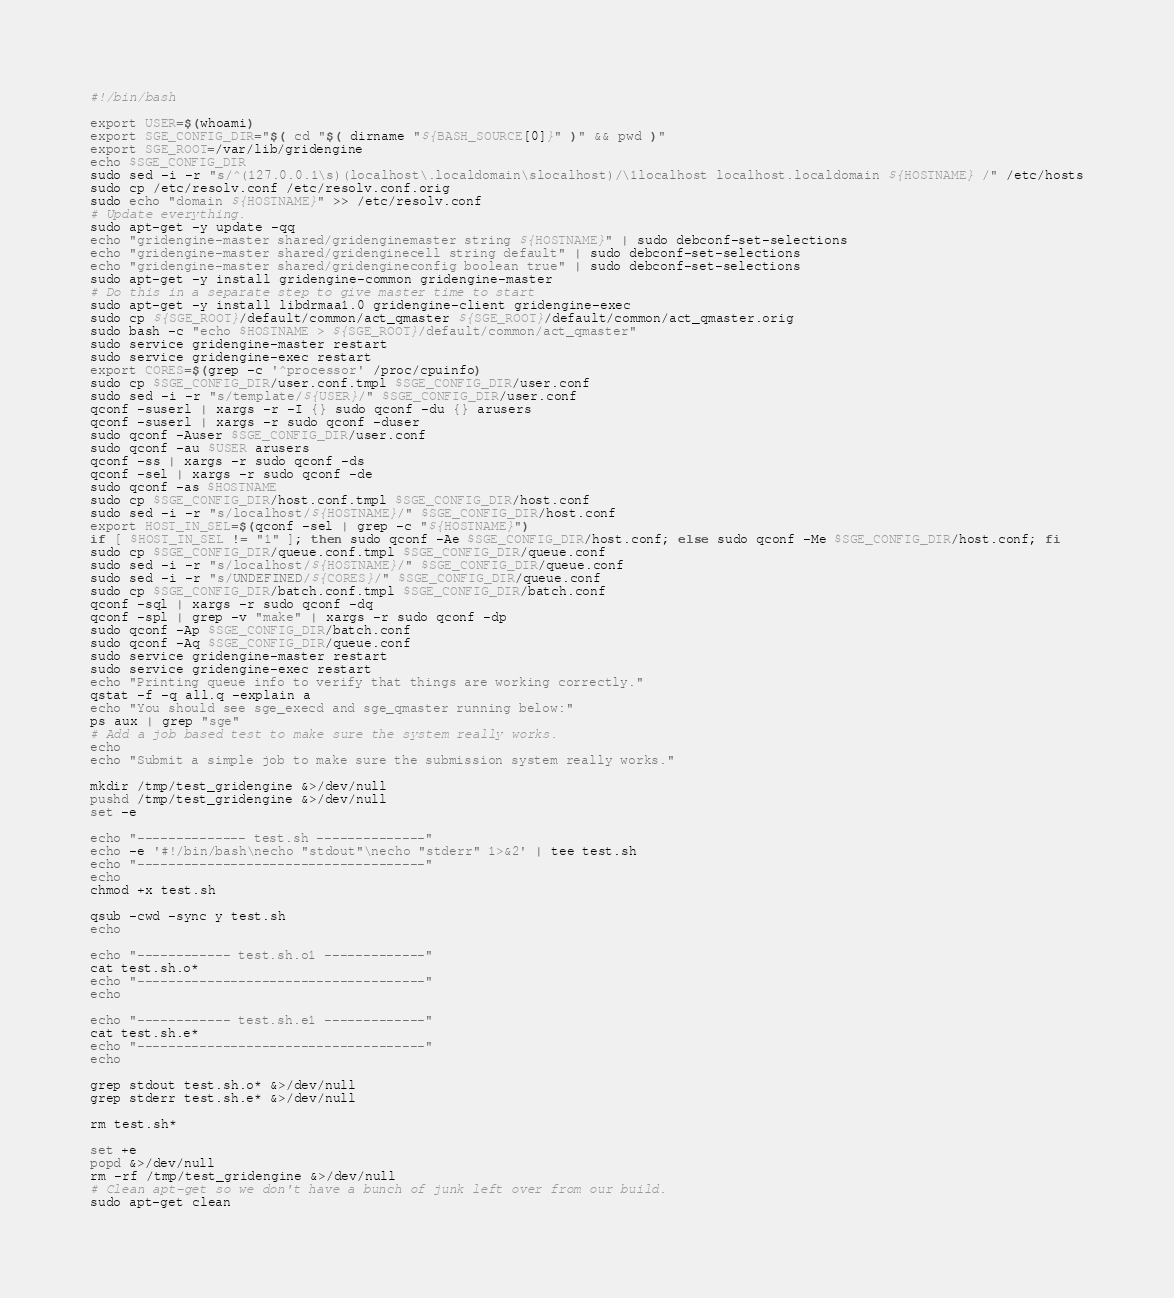Convert code to text. <code><loc_0><loc_0><loc_500><loc_500><_Bash_>#!/bin/bash

export USER=$(whoami)
export SGE_CONFIG_DIR="$( cd "$( dirname "${BASH_SOURCE[0]}" )" && pwd )"
export SGE_ROOT=/var/lib/gridengine
echo $SGE_CONFIG_DIR
sudo sed -i -r "s/^(127.0.0.1\s)(localhost\.localdomain\slocalhost)/\1localhost localhost.localdomain ${HOSTNAME} /" /etc/hosts
sudo cp /etc/resolv.conf /etc/resolv.conf.orig
sudo echo "domain ${HOSTNAME}" >> /etc/resolv.conf
# Update everything.
sudo apt-get -y update -qq
echo "gridengine-master shared/gridenginemaster string ${HOSTNAME}" | sudo debconf-set-selections
echo "gridengine-master shared/gridenginecell string default" | sudo debconf-set-selections
echo "gridengine-master shared/gridengineconfig boolean true" | sudo debconf-set-selections
sudo apt-get -y install gridengine-common gridengine-master
# Do this in a separate step to give master time to start
sudo apt-get -y install libdrmaa1.0 gridengine-client gridengine-exec
sudo cp ${SGE_ROOT}/default/common/act_qmaster ${SGE_ROOT}/default/common/act_qmaster.orig
sudo bash -c "echo $HOSTNAME > ${SGE_ROOT}/default/common/act_qmaster"
sudo service gridengine-master restart
sudo service gridengine-exec restart
export CORES=$(grep -c '^processor' /proc/cpuinfo)
sudo cp $SGE_CONFIG_DIR/user.conf.tmpl $SGE_CONFIG_DIR/user.conf
sudo sed -i -r "s/template/${USER}/" $SGE_CONFIG_DIR/user.conf
qconf -suserl | xargs -r -I {} sudo qconf -du {} arusers
qconf -suserl | xargs -r sudo qconf -duser
sudo qconf -Auser $SGE_CONFIG_DIR/user.conf
sudo qconf -au $USER arusers
qconf -ss | xargs -r sudo qconf -ds
qconf -sel | xargs -r sudo qconf -de
sudo qconf -as $HOSTNAME
sudo cp $SGE_CONFIG_DIR/host.conf.tmpl $SGE_CONFIG_DIR/host.conf
sudo sed -i -r "s/localhost/${HOSTNAME}/" $SGE_CONFIG_DIR/host.conf
export HOST_IN_SEL=$(qconf -sel | grep -c "${HOSTNAME}")
if [ $HOST_IN_SEL != "1" ]; then sudo qconf -Ae $SGE_CONFIG_DIR/host.conf; else sudo qconf -Me $SGE_CONFIG_DIR/host.conf; fi
sudo cp $SGE_CONFIG_DIR/queue.conf.tmpl $SGE_CONFIG_DIR/queue.conf
sudo sed -i -r "s/localhost/${HOSTNAME}/" $SGE_CONFIG_DIR/queue.conf
sudo sed -i -r "s/UNDEFINED/${CORES}/" $SGE_CONFIG_DIR/queue.conf
sudo cp $SGE_CONFIG_DIR/batch.conf.tmpl $SGE_CONFIG_DIR/batch.conf
qconf -sql | xargs -r sudo qconf -dq
qconf -spl | grep -v "make" | xargs -r sudo qconf -dp
sudo qconf -Ap $SGE_CONFIG_DIR/batch.conf
sudo qconf -Aq $SGE_CONFIG_DIR/queue.conf
sudo service gridengine-master restart
sudo service gridengine-exec restart
echo "Printing queue info to verify that things are working correctly."
qstat -f -q all.q -explain a
echo "You should see sge_execd and sge_qmaster running below:"
ps aux | grep "sge"
# Add a job based test to make sure the system really works.
echo
echo "Submit a simple job to make sure the submission system really works."

mkdir /tmp/test_gridengine &>/dev/null
pushd /tmp/test_gridengine &>/dev/null
set -e

echo "-------------- test.sh --------------"
echo -e '#!/bin/bash\necho "stdout"\necho "stderr" 1>&2' | tee test.sh
echo "-------------------------------------"
echo
chmod +x test.sh

qsub -cwd -sync y test.sh
echo

echo "------------ test.sh.o1 -------------"
cat test.sh.o*
echo "-------------------------------------"
echo

echo "------------ test.sh.e1 -------------"
cat test.sh.e*
echo "-------------------------------------"
echo

grep stdout test.sh.o* &>/dev/null
grep stderr test.sh.e* &>/dev/null

rm test.sh*

set +e
popd &>/dev/null
rm -rf /tmp/test_gridengine &>/dev/null
# Clean apt-get so we don't have a bunch of junk left over from our build.
sudo apt-get clean
</code> 